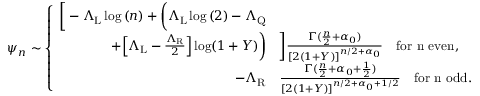<formula> <loc_0><loc_0><loc_500><loc_500>\psi _ { n } \sim \left \{ \begin{array} { r l } { \left [ - \Lambda _ { L } \log { ( n ) } + \left ( \Lambda _ { L } \log { ( 2 ) } - \Lambda _ { Q } } \\ { + \left [ \Lambda _ { L } - \frac { \Lambda _ { R } } { 2 } \right ] \log ( 1 + Y ) \right ) } & { \right ] \frac { \Gamma ( \frac { n } { 2 } + \alpha _ { 0 } ) } { [ 2 ( 1 + Y ) ] ^ { n / 2 + \alpha _ { 0 } } } \quad f o r n e v e n , } \\ { - \Lambda _ { R } } & { \frac { \Gamma ( \frac { n } { 2 } + { \alpha _ { 0 } + \frac { 1 } { 2 } } ) } { [ 2 ( 1 + Y ) ] ^ { n / 2 + { \alpha _ { 0 } + 1 / 2 } } } \quad f o r n o d d . } \end{array}</formula> 